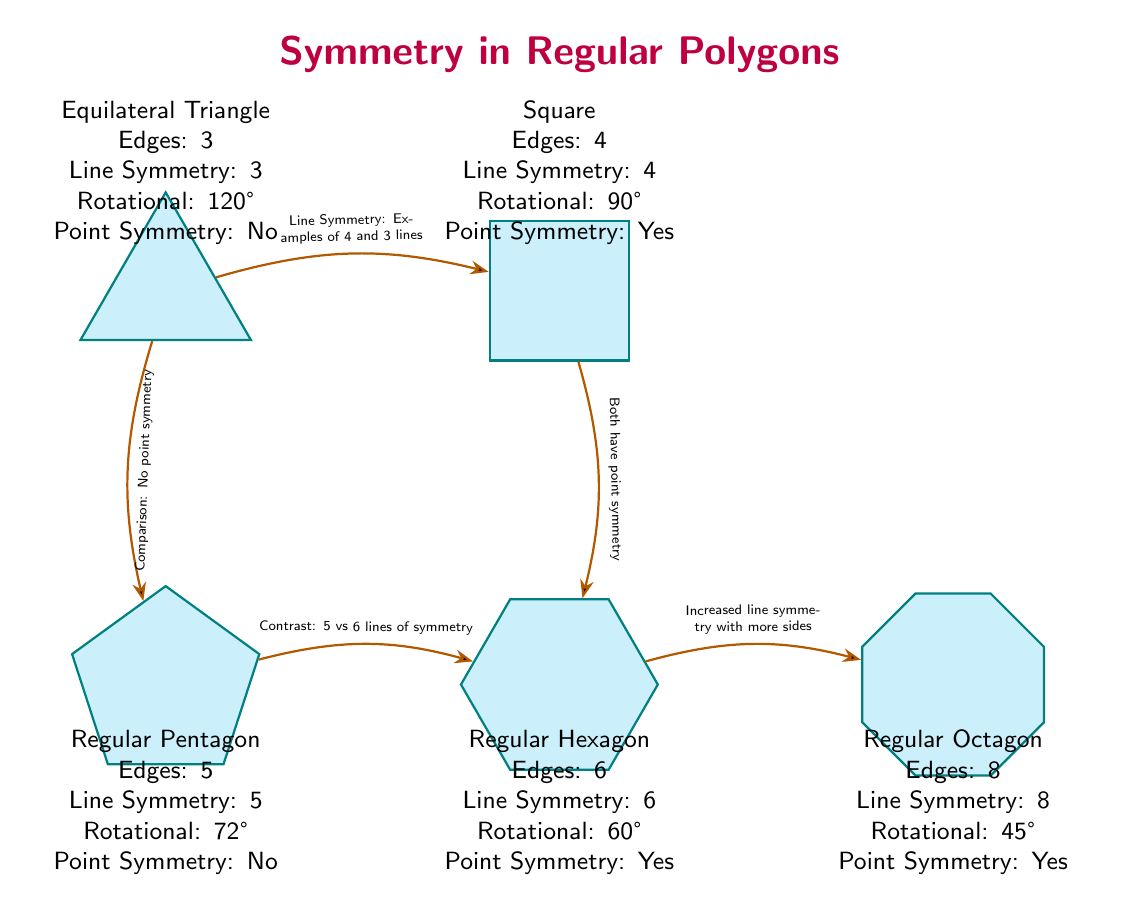What is the number of edges in a square? The diagram specifies that the square has 4 edges, which is stated in the info box next to the square.
Answer: 4 How many lines of symmetry does a regular hexagon have? According to the information provided in the hexagon's info box, it has 6 lines of symmetry.
Answer: 6 What is the rotational symmetry degree of a regular pentagon? The info box for the pentagon indicates that its rotational symmetry is 72 degrees.
Answer: 72° How does the number of lines of symmetry compare between the regular pentagon and regular hexagon? The pentagon has 5 lines of symmetry, while the hexagon has 6. Therefore, the hexagon has one more line of symmetry than the pentagon.
Answer: 6 vs 5 Which polygons exhibit point symmetry? The diagram highlights that both the square and the hexagon possess point symmetry, as stated in their respective info boxes.
Answer: Square, Hexagon What would be the line symmetry of a triangle compared to a square? The triangle has 3 lines of symmetry while the square has 4 lines of symmetry; thus, the triangle has one less line of symmetry compared to the square.
Answer: 3 vs 4 In terms of rotational symmetry, how do the square and octagon compare? The square has a rotational symmetry of 90 degrees, while the octagon has a rotational symmetry of 45 degrees. Therefore, the square has a larger rotational symmetry than the octagon.
Answer: 90° vs 45° Which regular polygon has the highest number of edges in the diagram? Among the polygons presented, the regular octagon has the highest number of edges, specifically 8.
Answer: 8 What type of symmetry does the equilateral triangle not exhibit? The info box for the triangle states that it does not have point symmetry, as it contrasts with the other polygons that do.
Answer: Point Symmetry 